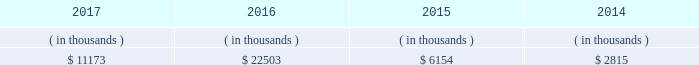Is expected to begin by late-2018 , after the necessary information technology infrastructure is in place .
Entergy louisiana proposed to recover the cost of ami through the implementation of a customer charge , net of certain benefits , phased in over the period 2019 through 2022 .
The parties reached an uncontested stipulation permitting implementation of entergy louisiana 2019s proposed ami system , with modifications to the proposed customer charge .
In july 2017 the lpsc approved the stipulation .
Entergy louisiana expects to recover the undepreciated balance of its existing meters through a regulatory asset at current depreciation rates .
Sources of capital entergy louisiana 2019s sources to meet its capital requirements include : 2022 internally generated funds ; 2022 cash on hand ; 2022 debt or preferred membership interest issuances ; and 2022 bank financing under new or existing facilities .
Entergy louisiana may refinance , redeem , or otherwise retire debt prior to maturity , to the extent market conditions and interest rates are favorable .
All debt and common and preferred membership interest issuances by entergy louisiana require prior regulatory approval .
Preferred membership interest and debt issuances are also subject to issuance tests set forth in its bond indentures and other agreements .
Entergy louisiana has sufficient capacity under these tests to meet its foreseeable capital needs .
Entergy louisiana 2019s receivables from the money pool were as follows as of december 31 for each of the following years. .
See note 4 to the financial statements for a description of the money pool .
Entergy louisiana has a credit facility in the amount of $ 350 million scheduled to expire in august 2022 .
The credit facility allows entergy louisiana to issue letters of credit against $ 15 million of the borrowing capacity of the facility .
As of december 31 , 2017 , there were no cash borrowings and a $ 9.1 million letter of credit outstanding under the credit facility .
In addition , entergy louisiana is a party to an uncommitted letter of credit facility as a means to post collateral to support its obligations to miso . a0 as of december 31 , 2017 , a $ 29.7 million letter of credit was outstanding under entergy louisiana 2019s uncommitted letter of credit a0facility .
See note 4 to the financial statements for additional discussion of the credit facilities .
The entergy louisiana nuclear fuel company variable interest entities have two separate credit facilities , one in the amount of $ 105 million and one in the amount of $ 85 million , both scheduled to expire in may 2019 .
As of december 31 , 2017 , $ 65.7 million of loans were outstanding under the credit facility for the entergy louisiana river bend nuclear fuel company variable interest entity .
As of december 31 , 2017 , $ 43.5 million in letters of credit to support a like amount of commercial paper issued and $ 36.4 million in loans were outstanding under the entergy louisiana waterford nuclear fuel company variable interest entity credit facility .
See note 4 to the financial statements for additional discussion of the nuclear fuel company variable interest entity credit facilities .
Entergy louisiana , llc and subsidiaries management 2019s financial discussion and analysis .
What was the sum of the entergy louisiana 2019s receivables from the money pool from 2014 to 2017? 
Computations: (2815 + ((11173 + 22503) + 6154))
Answer: 42645.0. 